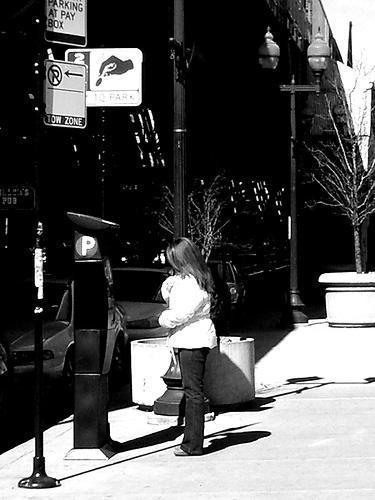How many signs have arrows?
Give a very brief answer. 1. 